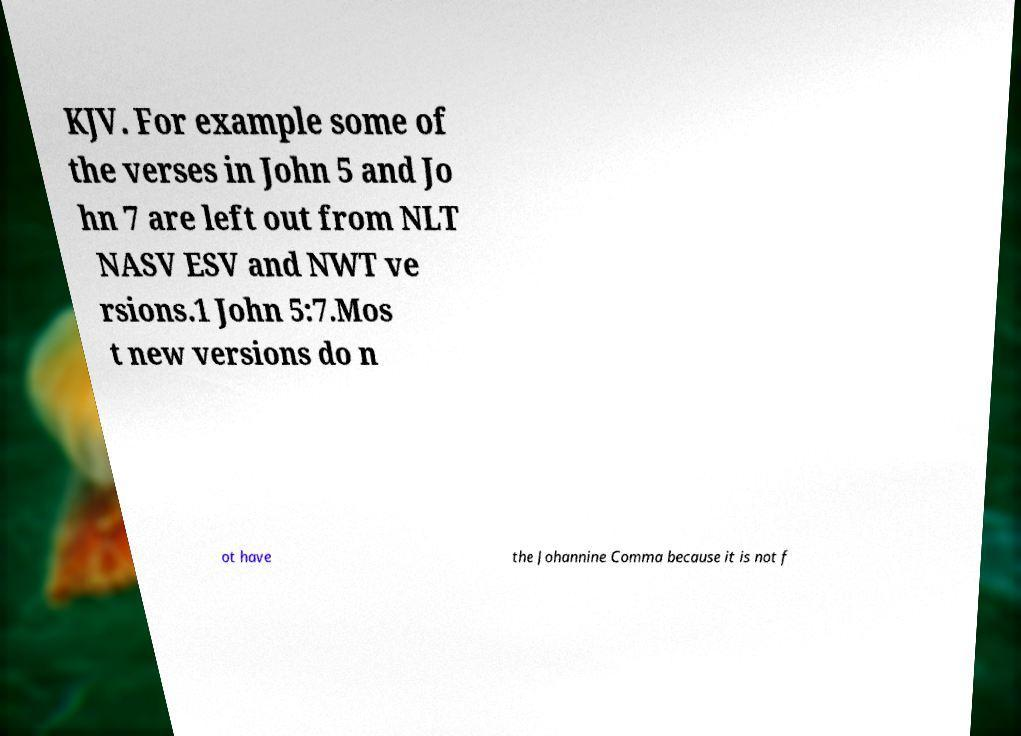For documentation purposes, I need the text within this image transcribed. Could you provide that? KJV. For example some of the verses in John 5 and Jo hn 7 are left out from NLT NASV ESV and NWT ve rsions.1 John 5:7.Mos t new versions do n ot have the Johannine Comma because it is not f 